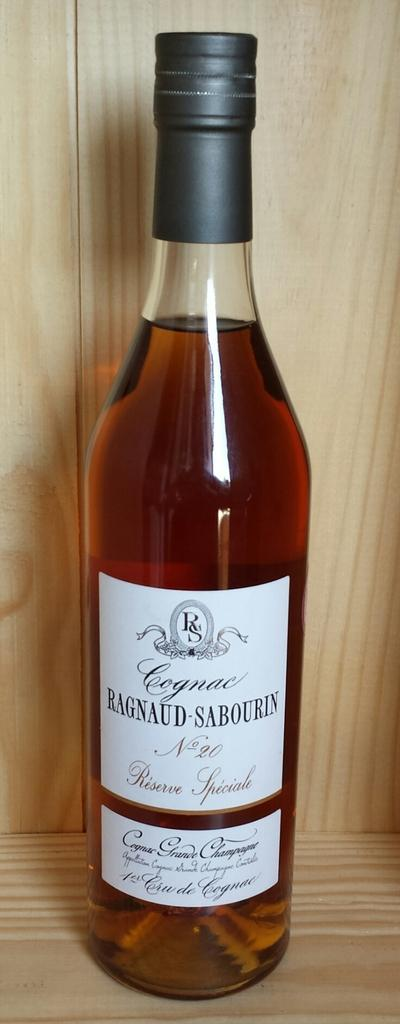<image>
Render a clear and concise summary of the photo. A bottle of Ragnaud-Sabourin cognac sits in a pale wood cabinet. 